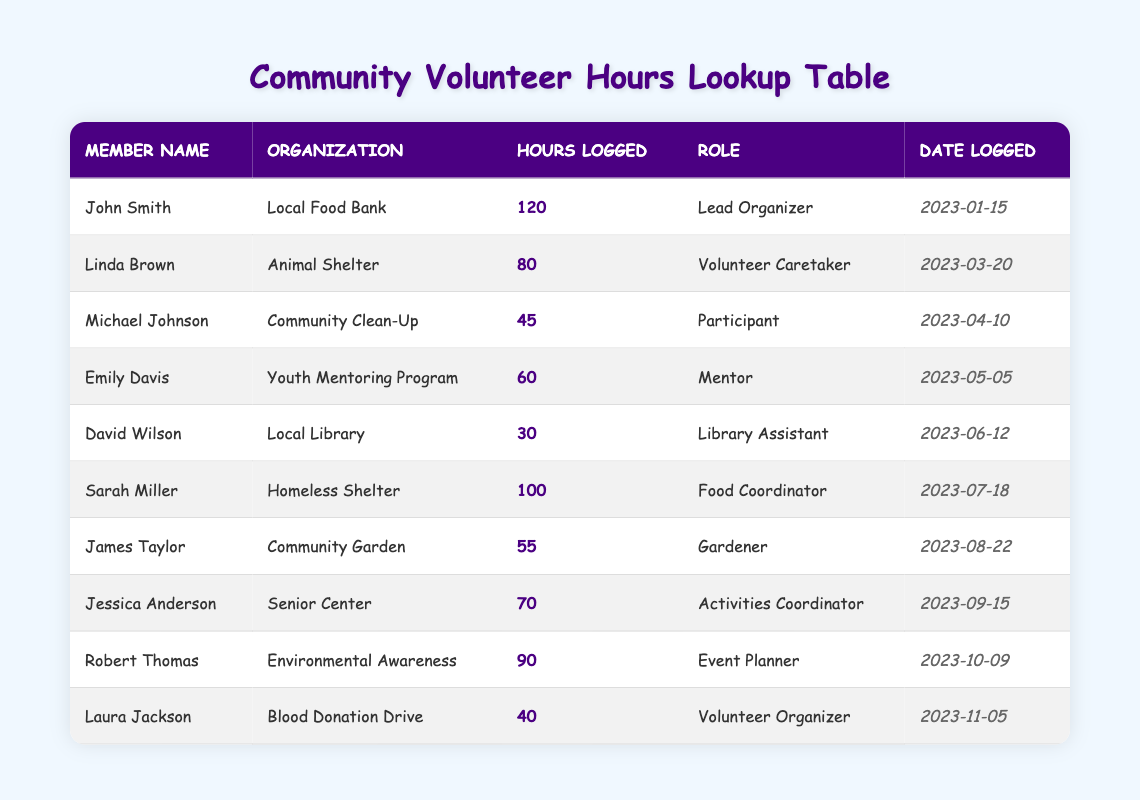What is the name of the member who logged the most hours in 2023? By scanning through the "Hours Logged" column in the table, we identify that John Smith logged 120 hours, which is the highest value compared to the other members.
Answer: John Smith How many hours did Sarah Miller log? Looking at the "Hours Logged" column, we find that Sarah Miller logged 100 hours for the Homeless Shelter.
Answer: 100 Which organization had the least hours logged, and who was the member associated with it? We need to check the "Hours Logged" values for each organization. David Wilson logged the least hours, with a total of 30 hours for the Local Library.
Answer: Local Library, David Wilson If you sum all the volunteer hours logged by members, how many hours is that? Adding all the hours from the "Hours Logged" column: 120 + 80 + 45 + 60 + 30 + 100 + 55 + 70 + 90 + 40 = 790 hours. So, the total sum of volunteer hours is 790.
Answer: 790 Did Emily Davis log more hours than Linda Brown? Comparing the hours logged by both members, Emily Davis logged 60 hours while Linda Brown logged 80 hours. Therefore, Emily did not log more hours than Linda.
Answer: No How many members logged more than 70 hours? Inspecting the "Hours Logged" column for values greater than 70, we find that John Smith, Sarah Miller, and Robert Thomas logged more than 70 hours, totaling three members.
Answer: 3 What is the average number of hours logged by all members? To find the average, we first sum all the hours (790) and then divide by the number of members who logged hours, which is 10. Therefore, 790 hours / 10 members = 79 hours per member on average.
Answer: 79 Which member logged hours in October, and how many hours did they log? Checking the "Date Logged" column, we see that Robert Thomas logged hours on October 9, with a total of 90 hours.
Answer: Robert Thomas, 90 Which organization had the most members contribute hours? Looking at the data, we find that different organizations had one member each logging hours. Thus, each organization listed has an equal number of contributors: one member each.
Answer: Each organization had one member 